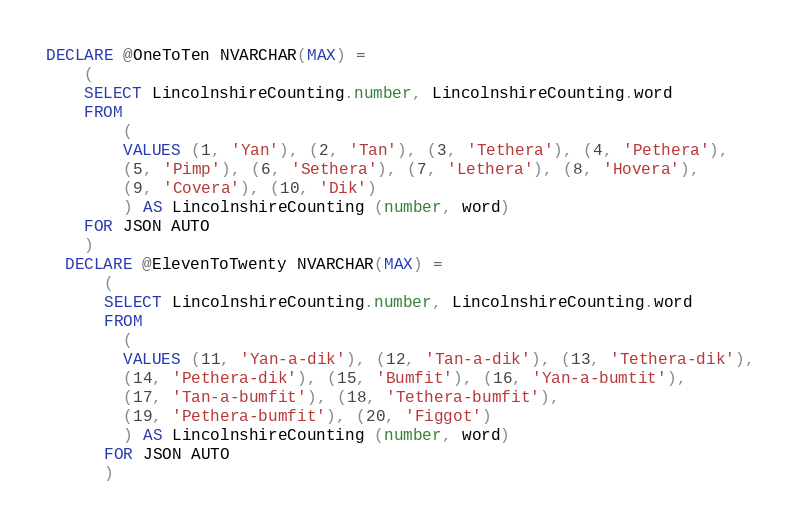Convert code to text. <code><loc_0><loc_0><loc_500><loc_500><_SQL_>DECLARE @OneToTen NVARCHAR(MAX) =
  	(
  	SELECT LincolnshireCounting.number, LincolnshireCounting.word
  	FROM
  		(
  		VALUES (1, 'Yan'), (2, 'Tan'), (3, 'Tethera'), (4, 'Pethera'),
  		(5, 'Pimp'), (6, 'Sethera'), (7, 'Lethera'), (8, 'Hovera'),
  		(9, 'Covera'), (10, 'Dik')
  		) AS LincolnshireCounting (number, word)
  	FOR JSON AUTO
  	)
  DECLARE @ElevenToTwenty NVARCHAR(MAX) =
      (
      SELECT LincolnshireCounting.number, LincolnshireCounting.word
      FROM
  		(
  		VALUES (11, 'Yan-a-dik'), (12, 'Tan-a-dik'), (13, 'Tethera-dik'),
  		(14, 'Pethera-dik'), (15, 'Bumfit'), (16, 'Yan-a-bumtit'),
  		(17, 'Tan-a-bumfit'), (18, 'Tethera-bumfit'),
  		(19, 'Pethera-bumfit'), (20, 'Figgot')
  		) AS LincolnshireCounting (number, word)
      FOR JSON AUTO
      )</code> 